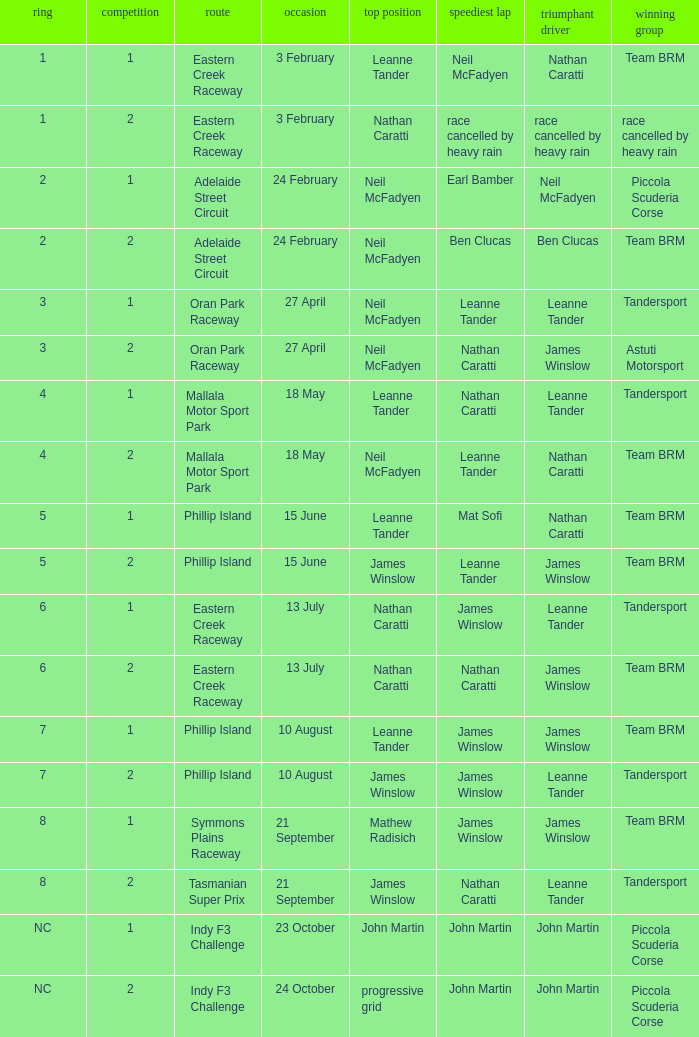Which race number in the Indy F3 Challenge circuit had John Martin in pole position? 1.0. 